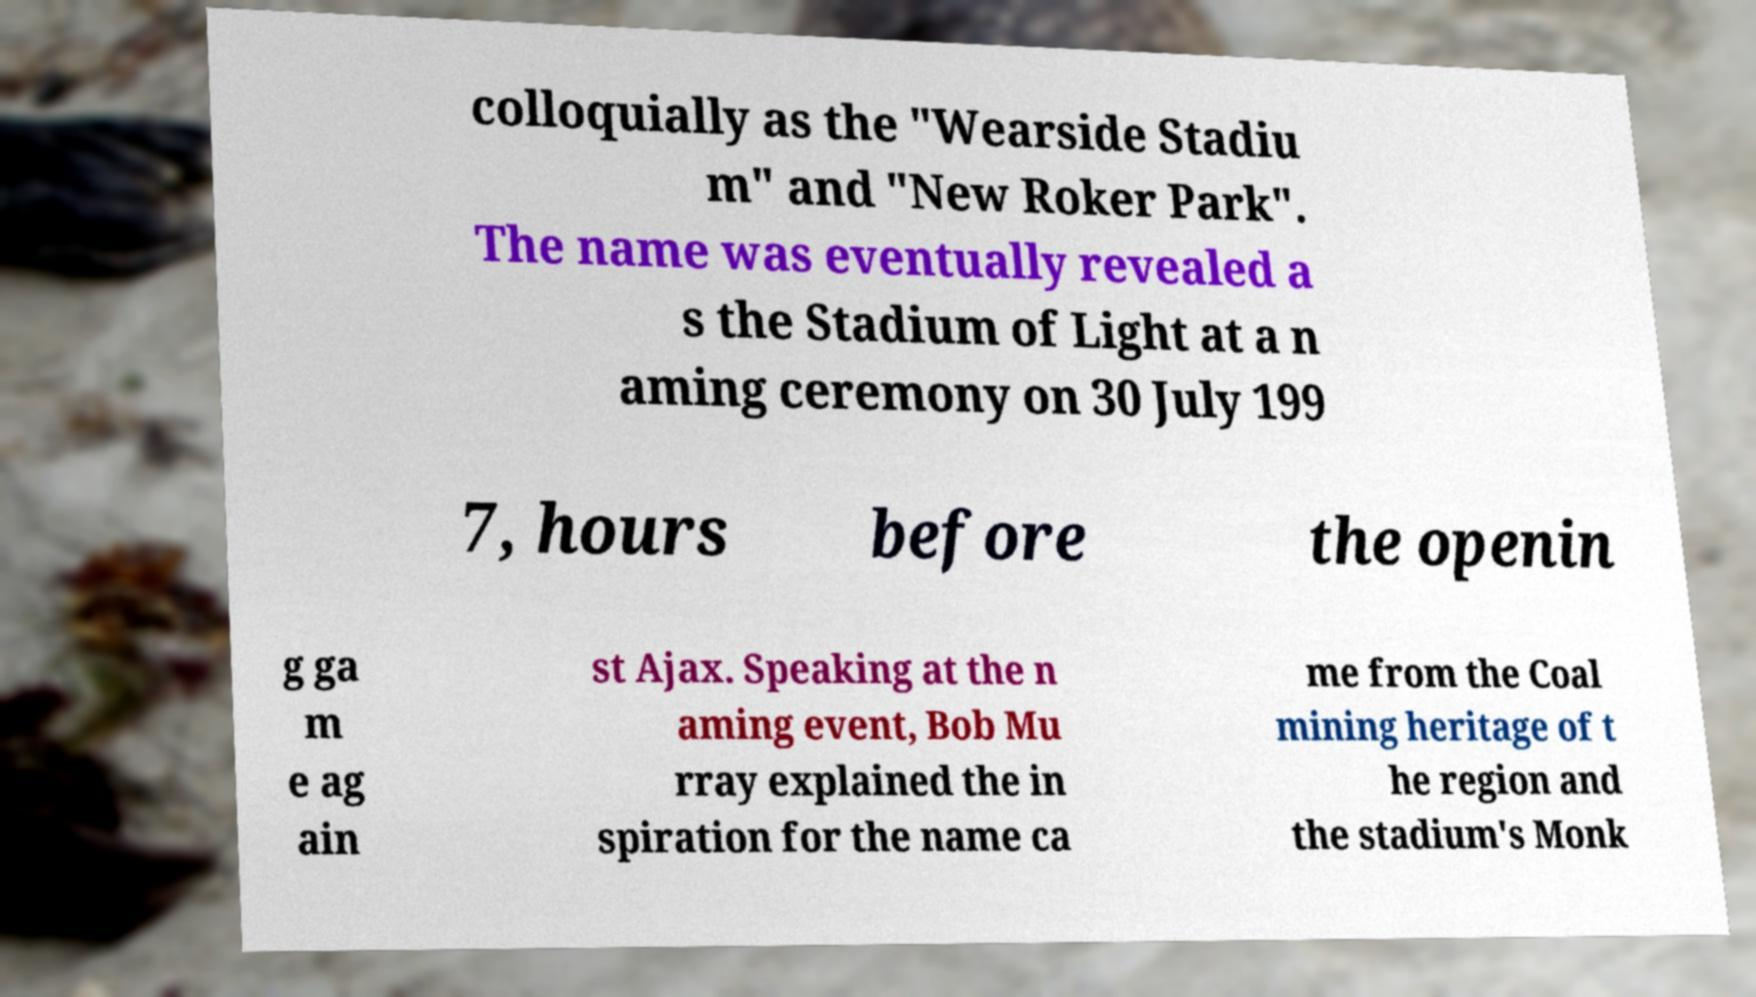What messages or text are displayed in this image? I need them in a readable, typed format. colloquially as the "Wearside Stadiu m" and "New Roker Park". The name was eventually revealed a s the Stadium of Light at a n aming ceremony on 30 July 199 7, hours before the openin g ga m e ag ain st Ajax. Speaking at the n aming event, Bob Mu rray explained the in spiration for the name ca me from the Coal mining heritage of t he region and the stadium's Monk 